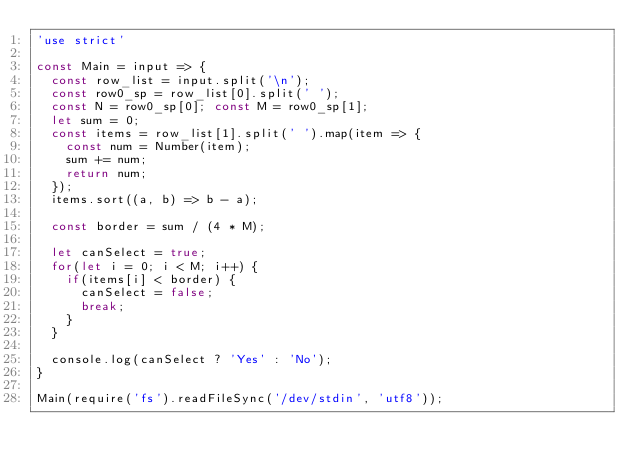Convert code to text. <code><loc_0><loc_0><loc_500><loc_500><_JavaScript_>'use strict'

const Main = input => {
  const row_list = input.split('\n');
  const row0_sp = row_list[0].split(' ');
  const N = row0_sp[0]; const M = row0_sp[1];
  let sum = 0;
  const items = row_list[1].split(' ').map(item => {
    const num = Number(item);
    sum += num;
    return num;
  });
  items.sort((a, b) => b - a);
  
  const border = sum / (4 * M);

  let canSelect = true;
  for(let i = 0; i < M; i++) {
    if(items[i] < border) {
      canSelect = false;
      break;
    }
  }

  console.log(canSelect ? 'Yes' : 'No');
}

Main(require('fs').readFileSync('/dev/stdin', 'utf8'));
</code> 